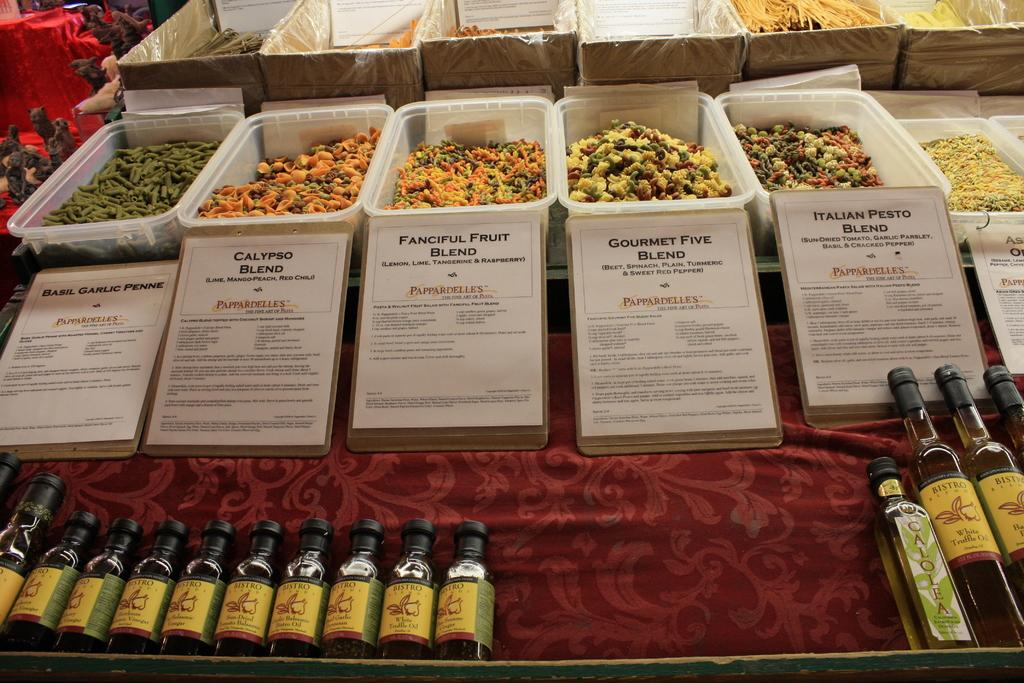What type of containers are visible in the image? There are plastic baskets in the image. What are the plastic baskets holding? There are food items in the plastic baskets. What else can be seen in the image besides the plastic baskets? There are bottles and boards in the image. What type of jam is being spread on the bean in the image? There is no jam or bean present in the image; it only features plastic baskets, food items, bottles, and boards. 